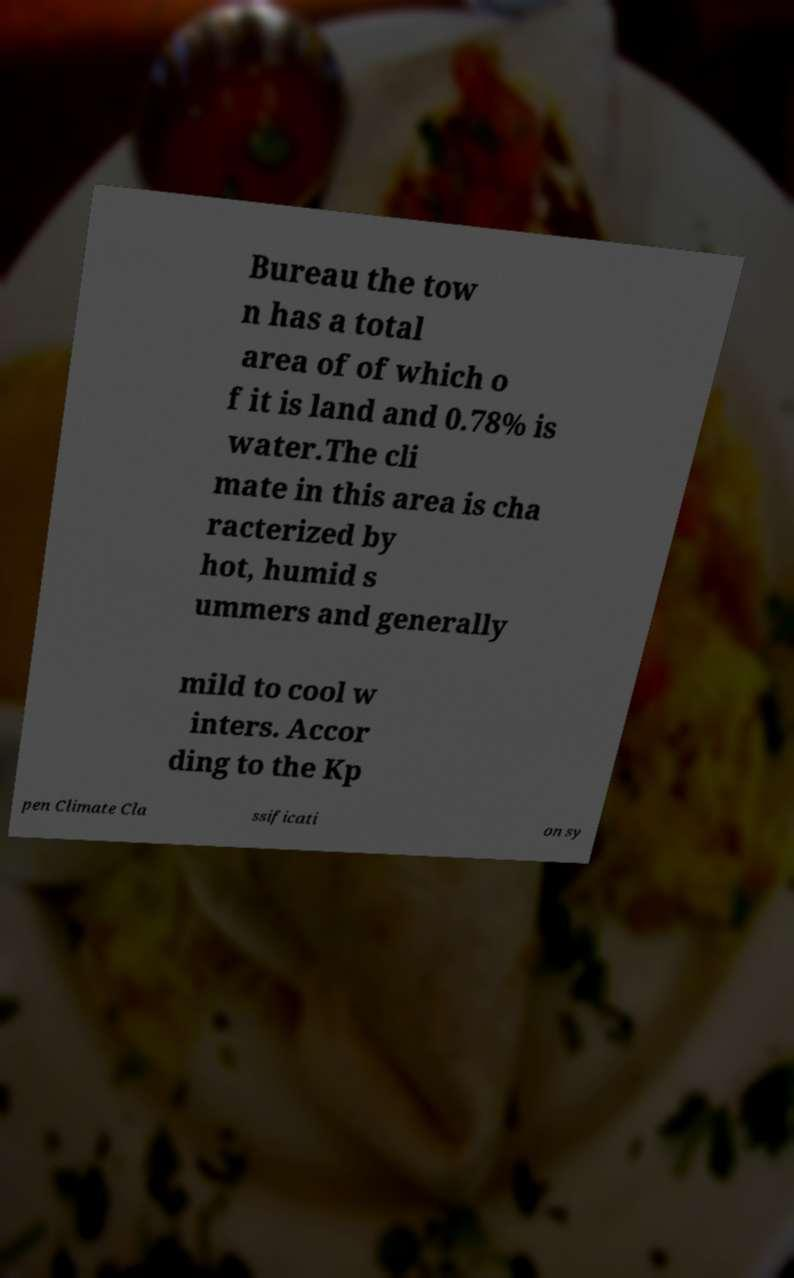Could you extract and type out the text from this image? Bureau the tow n has a total area of of which o f it is land and 0.78% is water.The cli mate in this area is cha racterized by hot, humid s ummers and generally mild to cool w inters. Accor ding to the Kp pen Climate Cla ssificati on sy 